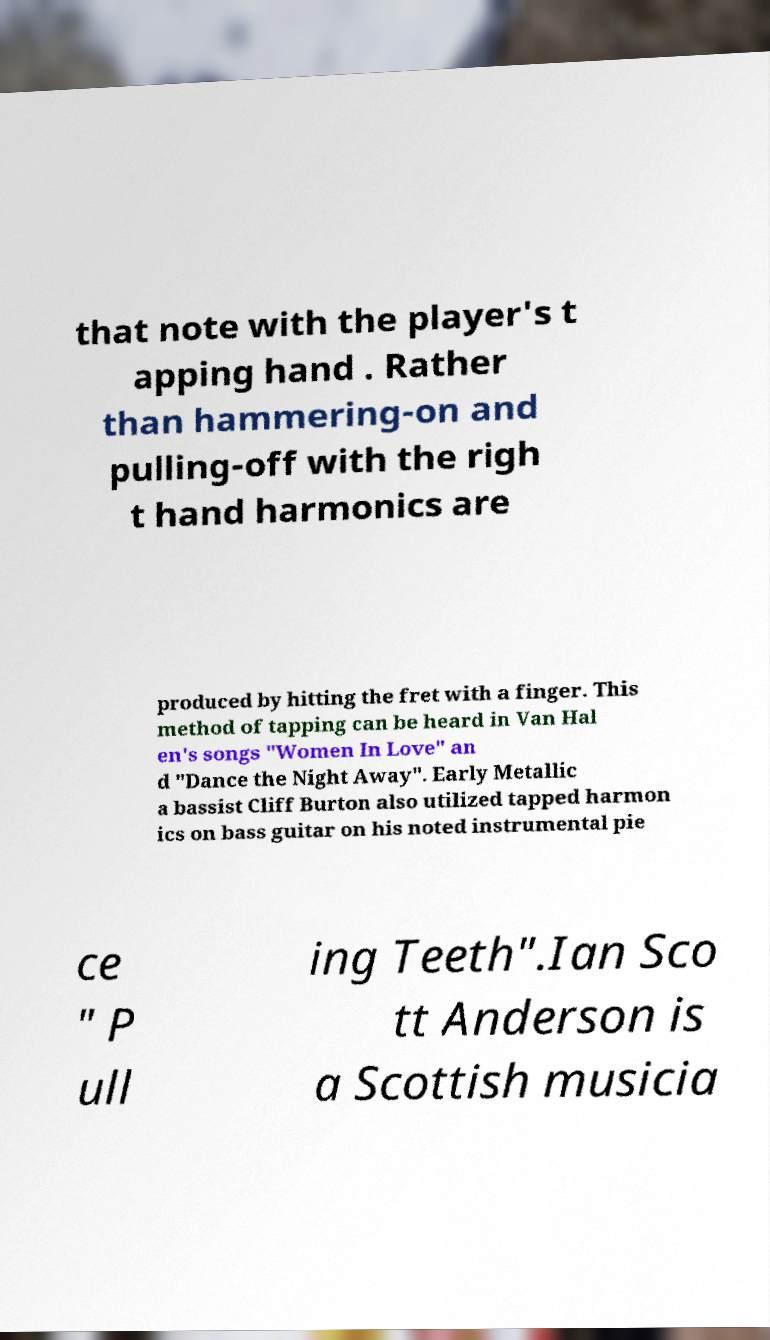I need the written content from this picture converted into text. Can you do that? that note with the player's t apping hand . Rather than hammering-on and pulling-off with the righ t hand harmonics are produced by hitting the fret with a finger. This method of tapping can be heard in Van Hal en's songs "Women In Love" an d "Dance the Night Away". Early Metallic a bassist Cliff Burton also utilized tapped harmon ics on bass guitar on his noted instrumental pie ce " P ull ing Teeth".Ian Sco tt Anderson is a Scottish musicia 